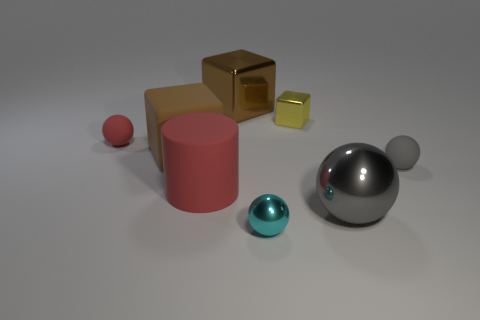Can you describe the colors and shapes of the objects seen in the image? Certainly! There are six objects with various colors and shapes: a red sphere, a pink cylinder, a gold cube, a small yellow cube, a large silver sphere, and a smaller teal sphere. 